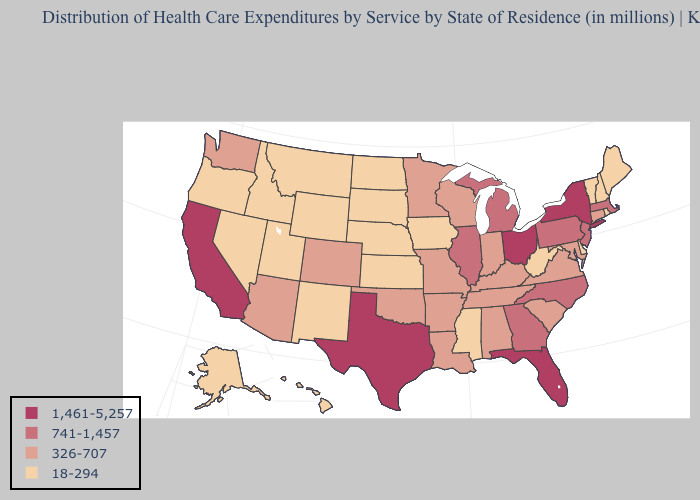Does the first symbol in the legend represent the smallest category?
Concise answer only. No. Does the map have missing data?
Concise answer only. No. Does Arkansas have the same value as Kentucky?
Give a very brief answer. Yes. What is the value of Georgia?
Be succinct. 741-1,457. What is the lowest value in states that border Maryland?
Give a very brief answer. 18-294. Among the states that border Massachusetts , does Rhode Island have the lowest value?
Write a very short answer. Yes. Which states hav the highest value in the South?
Write a very short answer. Florida, Texas. What is the value of Nevada?
Answer briefly. 18-294. What is the value of Maryland?
Quick response, please. 326-707. Which states have the lowest value in the MidWest?
Keep it brief. Iowa, Kansas, Nebraska, North Dakota, South Dakota. Among the states that border Georgia , does Florida have the lowest value?
Concise answer only. No. Does the first symbol in the legend represent the smallest category?
Answer briefly. No. What is the highest value in states that border New Jersey?
Write a very short answer. 1,461-5,257. What is the highest value in the USA?
Write a very short answer. 1,461-5,257. Does Louisiana have a higher value than Indiana?
Write a very short answer. No. 